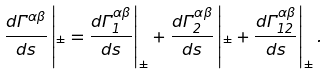<formula> <loc_0><loc_0><loc_500><loc_500>\frac { d \Gamma ^ { \alpha \beta } } { d s } \left | _ { \pm } = \frac { d \Gamma ^ { \alpha \beta } _ { 1 } } { d s } \right | _ { \pm } + \frac { d \Gamma ^ { \alpha \beta } _ { 2 } } { d s } \left | _ { \pm } + \frac { d \Gamma ^ { \alpha \beta } _ { 1 2 } } { d s } \right | _ { \pm } .</formula> 